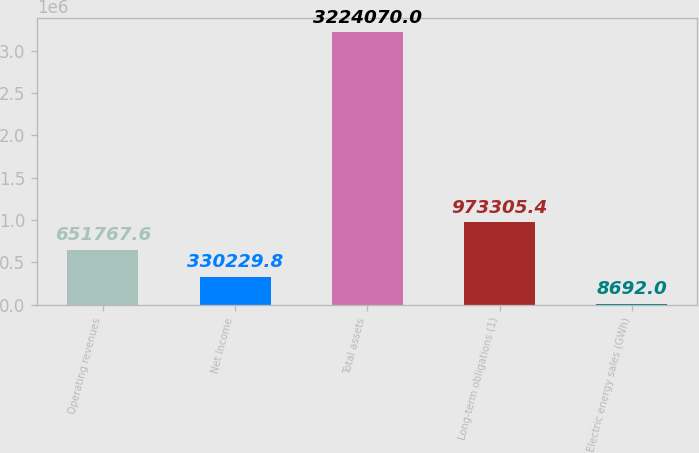Convert chart. <chart><loc_0><loc_0><loc_500><loc_500><bar_chart><fcel>Operating revenues<fcel>Net Income<fcel>Total assets<fcel>Long-term obligations (1)<fcel>Electric energy sales (GWh)<nl><fcel>651768<fcel>330230<fcel>3.22407e+06<fcel>973305<fcel>8692<nl></chart> 